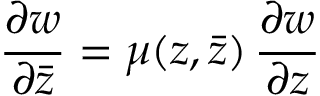<formula> <loc_0><loc_0><loc_500><loc_500>\frac { \partial w } { \partial \bar { z } } = \mu ( z , \bar { z } ) \, \frac { \partial w } { \partial z }</formula> 